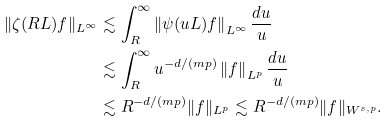<formula> <loc_0><loc_0><loc_500><loc_500>\| \zeta ( R L ) f \| _ { L ^ { \infty } } & \lesssim \int _ { R } ^ { \infty } \left \| \psi ( u L ) f \right \| _ { L ^ { \infty } } \frac { d u } { u } \\ & \lesssim \int _ { R } ^ { \infty } u ^ { - d / ( m p ) } \left \| f \right \| _ { L ^ { p } } \frac { d u } { u } \\ & \lesssim R ^ { - d / ( m p ) } \| f \| _ { L ^ { p } } \lesssim R ^ { - d / ( m p ) } \| f \| _ { W ^ { s , p } } .</formula> 